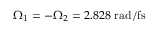<formula> <loc_0><loc_0><loc_500><loc_500>\Omega _ { 1 } = - \Omega _ { 2 } = 2 . 8 2 8 r a d / f s</formula> 